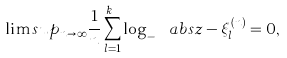<formula> <loc_0><loc_0><loc_500><loc_500>\lim s u p _ { n \to \infty } \frac { 1 } { n } \sum _ { l = 1 } ^ { k _ { n } } \log _ { - } { \ a b s { z - \xi _ { l } ^ { ( n ) } } } = 0 ,</formula> 